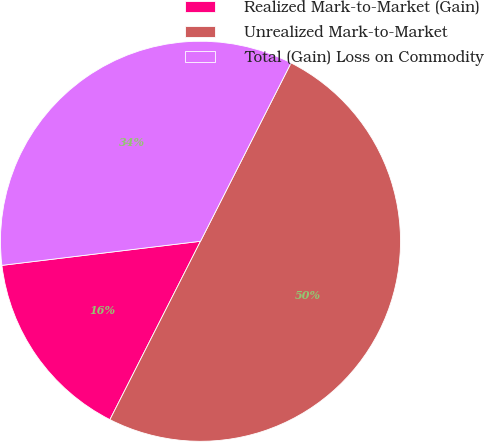<chart> <loc_0><loc_0><loc_500><loc_500><pie_chart><fcel>Realized Mark-to-Market (Gain)<fcel>Unrealized Mark-to-Market<fcel>Total (Gain) Loss on Commodity<nl><fcel>15.6%<fcel>50.0%<fcel>34.4%<nl></chart> 